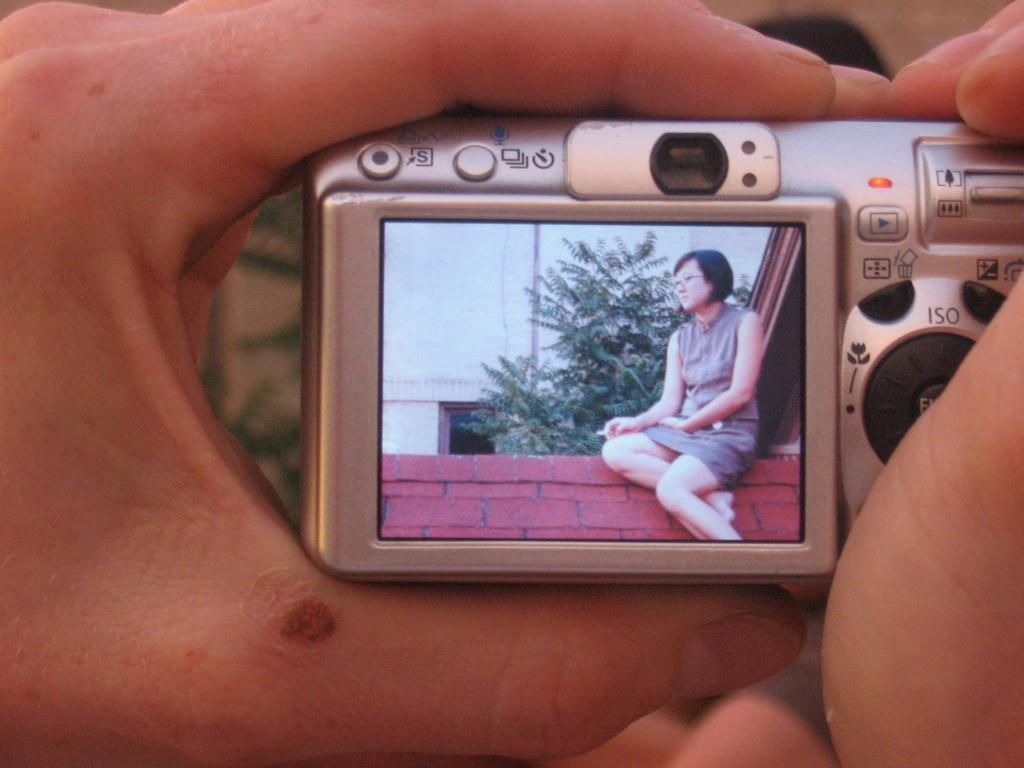<image>
Give a short and clear explanation of the subsequent image. One of the buttons on the camera is for changing the ISO setting 